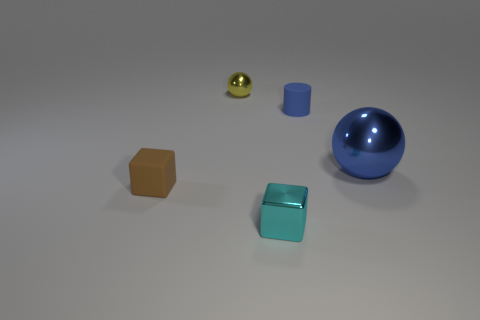Is there a cylinder of the same color as the large sphere?
Keep it short and to the point. Yes. There is a sphere that is the same color as the cylinder; what is it made of?
Your response must be concise. Metal. What size is the cylinder that is the same color as the big metal thing?
Offer a terse response. Small. Are there more small matte objects than small purple matte balls?
Make the answer very short. Yes. What shape is the tiny thing behind the tiny object that is to the right of the object that is in front of the tiny brown rubber block?
Offer a very short reply. Sphere. Are the cube that is on the left side of the small cyan block and the blue thing on the left side of the large blue ball made of the same material?
Provide a short and direct response. Yes. There is a blue object that is the same material as the cyan thing; what is its shape?
Keep it short and to the point. Sphere. Is there any other thing of the same color as the large thing?
Offer a terse response. Yes. What number of small red metallic things are there?
Make the answer very short. 0. What material is the tiny object that is behind the blue thing behind the large blue metallic object made of?
Offer a very short reply. Metal. 